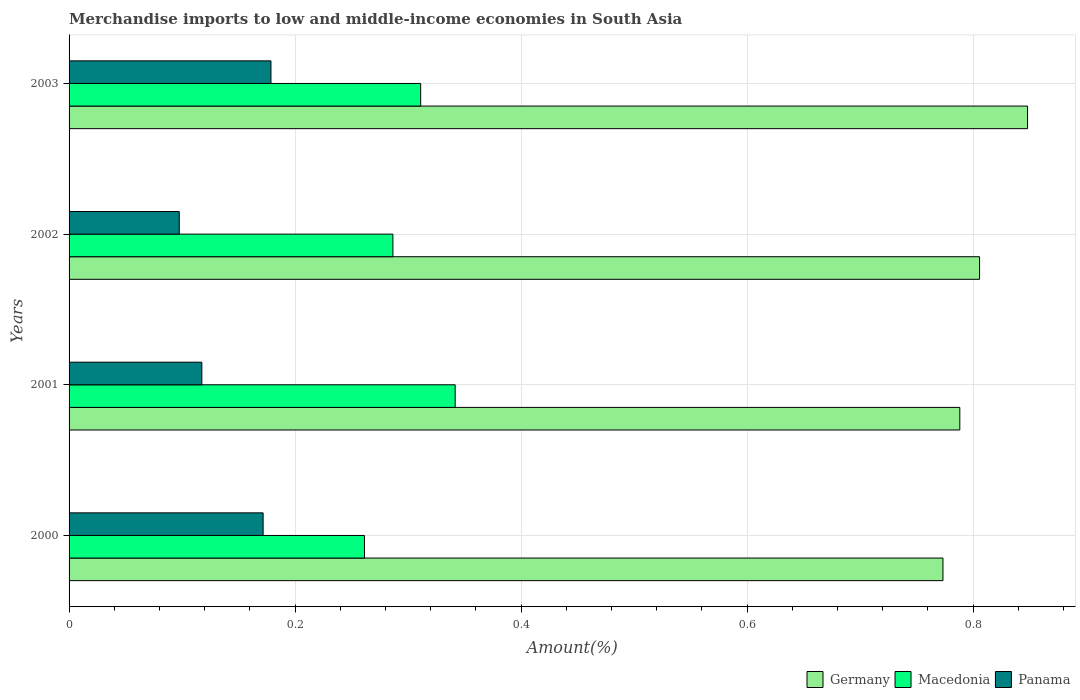How many groups of bars are there?
Offer a very short reply. 4. Are the number of bars per tick equal to the number of legend labels?
Keep it short and to the point. Yes. In how many cases, is the number of bars for a given year not equal to the number of legend labels?
Your answer should be compact. 0. What is the percentage of amount earned from merchandise imports in Panama in 2001?
Your answer should be very brief. 0.12. Across all years, what is the maximum percentage of amount earned from merchandise imports in Panama?
Provide a short and direct response. 0.18. Across all years, what is the minimum percentage of amount earned from merchandise imports in Macedonia?
Ensure brevity in your answer.  0.26. In which year was the percentage of amount earned from merchandise imports in Germany maximum?
Provide a short and direct response. 2003. In which year was the percentage of amount earned from merchandise imports in Germany minimum?
Offer a terse response. 2000. What is the total percentage of amount earned from merchandise imports in Germany in the graph?
Provide a short and direct response. 3.22. What is the difference between the percentage of amount earned from merchandise imports in Germany in 2001 and that in 2003?
Your answer should be very brief. -0.06. What is the difference between the percentage of amount earned from merchandise imports in Panama in 2000 and the percentage of amount earned from merchandise imports in Germany in 2003?
Provide a short and direct response. -0.68. What is the average percentage of amount earned from merchandise imports in Germany per year?
Your answer should be very brief. 0.8. In the year 2001, what is the difference between the percentage of amount earned from merchandise imports in Macedonia and percentage of amount earned from merchandise imports in Germany?
Provide a short and direct response. -0.45. In how many years, is the percentage of amount earned from merchandise imports in Macedonia greater than 0.56 %?
Your answer should be compact. 0. What is the ratio of the percentage of amount earned from merchandise imports in Germany in 2000 to that in 2001?
Give a very brief answer. 0.98. Is the difference between the percentage of amount earned from merchandise imports in Macedonia in 2000 and 2001 greater than the difference between the percentage of amount earned from merchandise imports in Germany in 2000 and 2001?
Give a very brief answer. No. What is the difference between the highest and the second highest percentage of amount earned from merchandise imports in Macedonia?
Offer a terse response. 0.03. What is the difference between the highest and the lowest percentage of amount earned from merchandise imports in Macedonia?
Your answer should be very brief. 0.08. What does the 1st bar from the bottom in 2002 represents?
Your answer should be very brief. Germany. How many bars are there?
Your answer should be very brief. 12. What is the difference between two consecutive major ticks on the X-axis?
Your response must be concise. 0.2. Does the graph contain any zero values?
Give a very brief answer. No. How many legend labels are there?
Provide a succinct answer. 3. What is the title of the graph?
Give a very brief answer. Merchandise imports to low and middle-income economies in South Asia. Does "Greenland" appear as one of the legend labels in the graph?
Give a very brief answer. No. What is the label or title of the X-axis?
Provide a succinct answer. Amount(%). What is the label or title of the Y-axis?
Make the answer very short. Years. What is the Amount(%) of Germany in 2000?
Provide a succinct answer. 0.77. What is the Amount(%) in Macedonia in 2000?
Offer a terse response. 0.26. What is the Amount(%) of Panama in 2000?
Offer a terse response. 0.17. What is the Amount(%) of Germany in 2001?
Provide a succinct answer. 0.79. What is the Amount(%) of Macedonia in 2001?
Provide a short and direct response. 0.34. What is the Amount(%) in Panama in 2001?
Provide a short and direct response. 0.12. What is the Amount(%) of Germany in 2002?
Provide a short and direct response. 0.81. What is the Amount(%) in Macedonia in 2002?
Your response must be concise. 0.29. What is the Amount(%) in Panama in 2002?
Give a very brief answer. 0.1. What is the Amount(%) in Germany in 2003?
Your answer should be compact. 0.85. What is the Amount(%) in Macedonia in 2003?
Your answer should be compact. 0.31. What is the Amount(%) of Panama in 2003?
Provide a succinct answer. 0.18. Across all years, what is the maximum Amount(%) in Germany?
Offer a terse response. 0.85. Across all years, what is the maximum Amount(%) of Macedonia?
Provide a succinct answer. 0.34. Across all years, what is the maximum Amount(%) in Panama?
Your response must be concise. 0.18. Across all years, what is the minimum Amount(%) in Germany?
Offer a terse response. 0.77. Across all years, what is the minimum Amount(%) in Macedonia?
Make the answer very short. 0.26. Across all years, what is the minimum Amount(%) of Panama?
Keep it short and to the point. 0.1. What is the total Amount(%) of Germany in the graph?
Make the answer very short. 3.22. What is the total Amount(%) of Macedonia in the graph?
Your answer should be very brief. 1.2. What is the total Amount(%) in Panama in the graph?
Your answer should be compact. 0.57. What is the difference between the Amount(%) of Germany in 2000 and that in 2001?
Keep it short and to the point. -0.01. What is the difference between the Amount(%) in Macedonia in 2000 and that in 2001?
Offer a terse response. -0.08. What is the difference between the Amount(%) in Panama in 2000 and that in 2001?
Offer a terse response. 0.05. What is the difference between the Amount(%) of Germany in 2000 and that in 2002?
Offer a terse response. -0.03. What is the difference between the Amount(%) in Macedonia in 2000 and that in 2002?
Provide a succinct answer. -0.03. What is the difference between the Amount(%) in Panama in 2000 and that in 2002?
Your answer should be compact. 0.07. What is the difference between the Amount(%) in Germany in 2000 and that in 2003?
Make the answer very short. -0.07. What is the difference between the Amount(%) in Macedonia in 2000 and that in 2003?
Your answer should be very brief. -0.05. What is the difference between the Amount(%) in Panama in 2000 and that in 2003?
Give a very brief answer. -0.01. What is the difference between the Amount(%) in Germany in 2001 and that in 2002?
Your answer should be compact. -0.02. What is the difference between the Amount(%) in Macedonia in 2001 and that in 2002?
Your answer should be compact. 0.06. What is the difference between the Amount(%) in Germany in 2001 and that in 2003?
Give a very brief answer. -0.06. What is the difference between the Amount(%) of Macedonia in 2001 and that in 2003?
Your answer should be very brief. 0.03. What is the difference between the Amount(%) in Panama in 2001 and that in 2003?
Offer a terse response. -0.06. What is the difference between the Amount(%) of Germany in 2002 and that in 2003?
Ensure brevity in your answer.  -0.04. What is the difference between the Amount(%) in Macedonia in 2002 and that in 2003?
Offer a terse response. -0.02. What is the difference between the Amount(%) in Panama in 2002 and that in 2003?
Provide a short and direct response. -0.08. What is the difference between the Amount(%) in Germany in 2000 and the Amount(%) in Macedonia in 2001?
Your response must be concise. 0.43. What is the difference between the Amount(%) in Germany in 2000 and the Amount(%) in Panama in 2001?
Provide a short and direct response. 0.66. What is the difference between the Amount(%) of Macedonia in 2000 and the Amount(%) of Panama in 2001?
Your answer should be compact. 0.14. What is the difference between the Amount(%) of Germany in 2000 and the Amount(%) of Macedonia in 2002?
Your response must be concise. 0.49. What is the difference between the Amount(%) in Germany in 2000 and the Amount(%) in Panama in 2002?
Your answer should be compact. 0.68. What is the difference between the Amount(%) in Macedonia in 2000 and the Amount(%) in Panama in 2002?
Your response must be concise. 0.16. What is the difference between the Amount(%) in Germany in 2000 and the Amount(%) in Macedonia in 2003?
Offer a terse response. 0.46. What is the difference between the Amount(%) of Germany in 2000 and the Amount(%) of Panama in 2003?
Provide a short and direct response. 0.59. What is the difference between the Amount(%) in Macedonia in 2000 and the Amount(%) in Panama in 2003?
Offer a very short reply. 0.08. What is the difference between the Amount(%) of Germany in 2001 and the Amount(%) of Macedonia in 2002?
Give a very brief answer. 0.5. What is the difference between the Amount(%) of Germany in 2001 and the Amount(%) of Panama in 2002?
Ensure brevity in your answer.  0.69. What is the difference between the Amount(%) of Macedonia in 2001 and the Amount(%) of Panama in 2002?
Provide a succinct answer. 0.24. What is the difference between the Amount(%) in Germany in 2001 and the Amount(%) in Macedonia in 2003?
Your answer should be compact. 0.48. What is the difference between the Amount(%) of Germany in 2001 and the Amount(%) of Panama in 2003?
Make the answer very short. 0.61. What is the difference between the Amount(%) in Macedonia in 2001 and the Amount(%) in Panama in 2003?
Provide a succinct answer. 0.16. What is the difference between the Amount(%) of Germany in 2002 and the Amount(%) of Macedonia in 2003?
Offer a terse response. 0.49. What is the difference between the Amount(%) of Germany in 2002 and the Amount(%) of Panama in 2003?
Your response must be concise. 0.63. What is the difference between the Amount(%) in Macedonia in 2002 and the Amount(%) in Panama in 2003?
Your answer should be very brief. 0.11. What is the average Amount(%) of Germany per year?
Your answer should be compact. 0.8. What is the average Amount(%) of Macedonia per year?
Your response must be concise. 0.3. What is the average Amount(%) in Panama per year?
Offer a very short reply. 0.14. In the year 2000, what is the difference between the Amount(%) of Germany and Amount(%) of Macedonia?
Your answer should be very brief. 0.51. In the year 2000, what is the difference between the Amount(%) in Germany and Amount(%) in Panama?
Your answer should be very brief. 0.6. In the year 2000, what is the difference between the Amount(%) in Macedonia and Amount(%) in Panama?
Provide a succinct answer. 0.09. In the year 2001, what is the difference between the Amount(%) in Germany and Amount(%) in Macedonia?
Ensure brevity in your answer.  0.45. In the year 2001, what is the difference between the Amount(%) in Germany and Amount(%) in Panama?
Offer a terse response. 0.67. In the year 2001, what is the difference between the Amount(%) of Macedonia and Amount(%) of Panama?
Ensure brevity in your answer.  0.22. In the year 2002, what is the difference between the Amount(%) of Germany and Amount(%) of Macedonia?
Provide a succinct answer. 0.52. In the year 2002, what is the difference between the Amount(%) of Germany and Amount(%) of Panama?
Make the answer very short. 0.71. In the year 2002, what is the difference between the Amount(%) in Macedonia and Amount(%) in Panama?
Ensure brevity in your answer.  0.19. In the year 2003, what is the difference between the Amount(%) of Germany and Amount(%) of Macedonia?
Provide a succinct answer. 0.54. In the year 2003, what is the difference between the Amount(%) of Germany and Amount(%) of Panama?
Your response must be concise. 0.67. In the year 2003, what is the difference between the Amount(%) in Macedonia and Amount(%) in Panama?
Your answer should be very brief. 0.13. What is the ratio of the Amount(%) in Germany in 2000 to that in 2001?
Your answer should be compact. 0.98. What is the ratio of the Amount(%) of Macedonia in 2000 to that in 2001?
Your answer should be compact. 0.77. What is the ratio of the Amount(%) of Panama in 2000 to that in 2001?
Your response must be concise. 1.46. What is the ratio of the Amount(%) in Germany in 2000 to that in 2002?
Your answer should be very brief. 0.96. What is the ratio of the Amount(%) in Macedonia in 2000 to that in 2002?
Give a very brief answer. 0.91. What is the ratio of the Amount(%) in Panama in 2000 to that in 2002?
Provide a short and direct response. 1.76. What is the ratio of the Amount(%) in Germany in 2000 to that in 2003?
Provide a short and direct response. 0.91. What is the ratio of the Amount(%) of Macedonia in 2000 to that in 2003?
Your response must be concise. 0.84. What is the ratio of the Amount(%) in Panama in 2000 to that in 2003?
Ensure brevity in your answer.  0.96. What is the ratio of the Amount(%) in Germany in 2001 to that in 2002?
Ensure brevity in your answer.  0.98. What is the ratio of the Amount(%) of Macedonia in 2001 to that in 2002?
Ensure brevity in your answer.  1.19. What is the ratio of the Amount(%) of Panama in 2001 to that in 2002?
Offer a very short reply. 1.21. What is the ratio of the Amount(%) in Germany in 2001 to that in 2003?
Provide a short and direct response. 0.93. What is the ratio of the Amount(%) of Macedonia in 2001 to that in 2003?
Offer a very short reply. 1.1. What is the ratio of the Amount(%) in Panama in 2001 to that in 2003?
Your response must be concise. 0.66. What is the ratio of the Amount(%) of Germany in 2002 to that in 2003?
Make the answer very short. 0.95. What is the ratio of the Amount(%) of Macedonia in 2002 to that in 2003?
Your answer should be very brief. 0.92. What is the ratio of the Amount(%) in Panama in 2002 to that in 2003?
Your answer should be compact. 0.55. What is the difference between the highest and the second highest Amount(%) in Germany?
Ensure brevity in your answer.  0.04. What is the difference between the highest and the second highest Amount(%) in Macedonia?
Ensure brevity in your answer.  0.03. What is the difference between the highest and the second highest Amount(%) of Panama?
Your response must be concise. 0.01. What is the difference between the highest and the lowest Amount(%) in Germany?
Give a very brief answer. 0.07. What is the difference between the highest and the lowest Amount(%) of Macedonia?
Ensure brevity in your answer.  0.08. What is the difference between the highest and the lowest Amount(%) of Panama?
Offer a terse response. 0.08. 